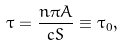Convert formula to latex. <formula><loc_0><loc_0><loc_500><loc_500>\tau = \frac { n \pi A } { c S } \equiv \tau _ { 0 } ,</formula> 